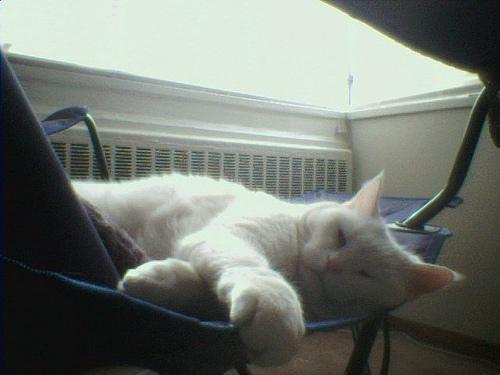How many chairs are in the photo?
Give a very brief answer. 1. How many blue truck cabs are there?
Give a very brief answer. 0. 